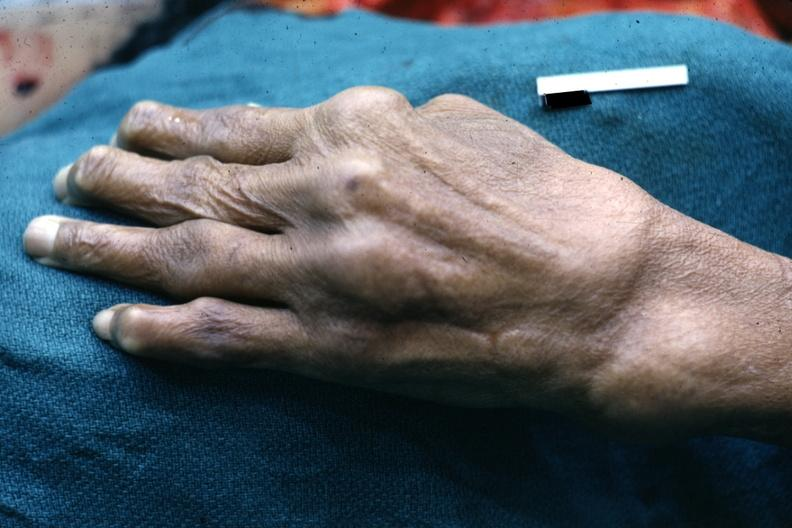does this image show enlarged joints typical of osteoarthritis?
Answer the question using a single word or phrase. Yes 